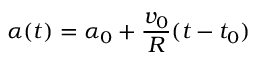<formula> <loc_0><loc_0><loc_500><loc_500>\alpha ( t ) = \alpha _ { 0 } + \frac { v _ { 0 } } { R } ( t - t _ { 0 } )</formula> 